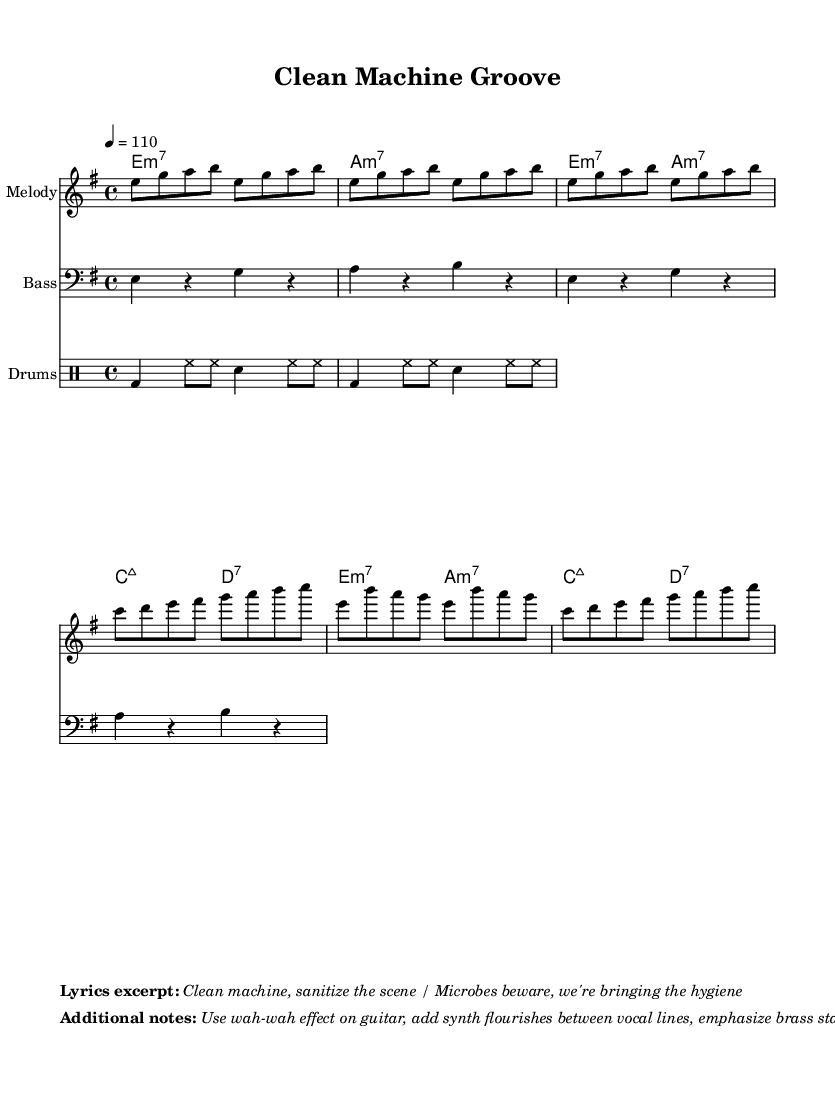What is the key signature of this music? The key signature is E minor, which is indicated by the presence of one sharp (F#) in the staff.
Answer: E minor What is the time signature of this music? The time signature is 4/4, which is shown at the beginning of the sheet music, indicating four beats per measure.
Answer: 4/4 What is the tempo marking of this piece? The tempo marking is indicated as "4 = 110," which specifies the speed at which the piece should be played, in beats per minute.
Answer: 110 How many measures are in the chorus section? By counting the measures in the section labeled as the chorus, there are four measures present.
Answer: Four What type of chords are used in the introduction? The introduction features minor seventh chords, as indicated by the chord labels provided on the sheet music.
Answer: Minor seventh What is the primary form of the bass line? The bass line consists of four-note patterns in a repetitive structure typically found in funk music.
Answer: Four-note patterns What effect is suggested to be used on the guitar? The suggested effect for the guitar is a wah-wah effect, which creates a distinctive tonal quality typical in funk genres.
Answer: Wah-wah effect 